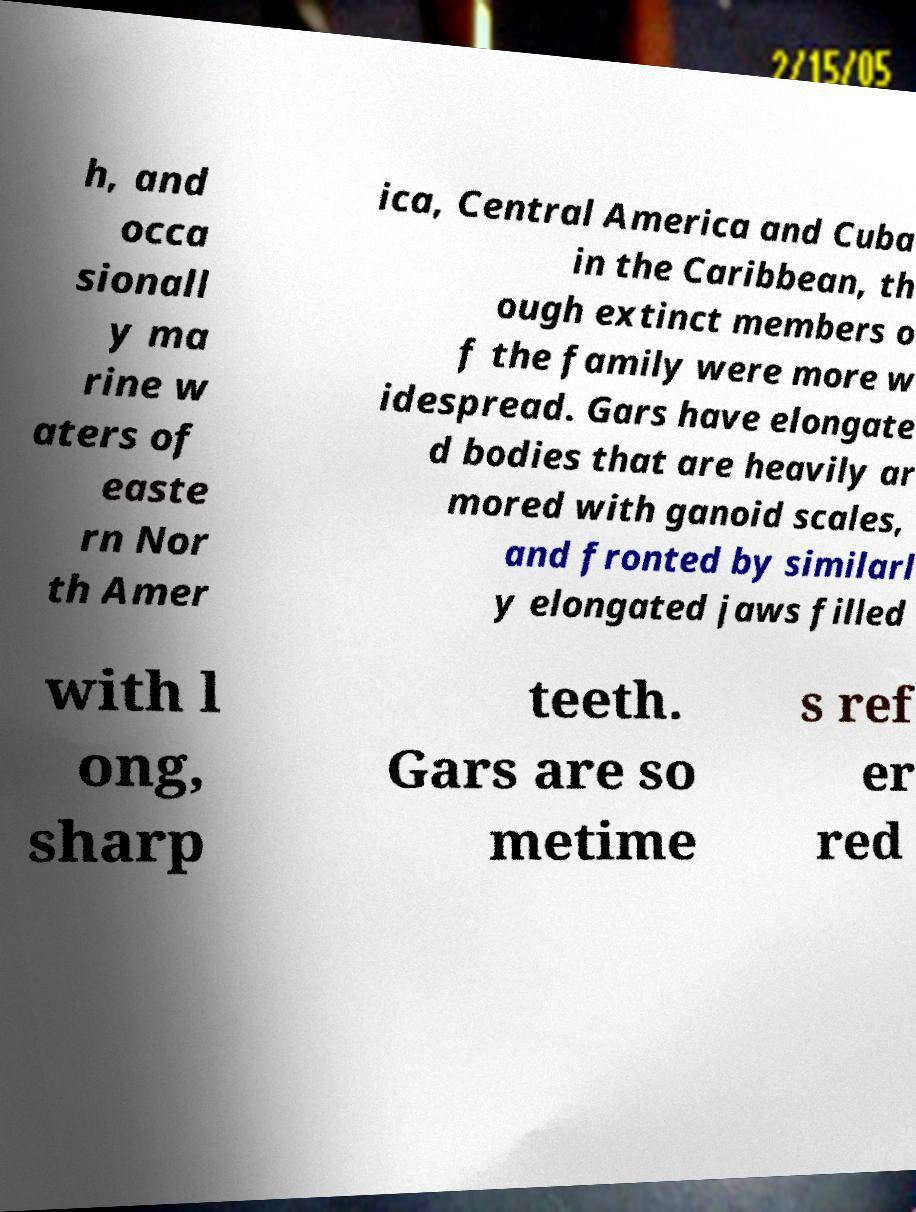For documentation purposes, I need the text within this image transcribed. Could you provide that? h, and occa sionall y ma rine w aters of easte rn Nor th Amer ica, Central America and Cuba in the Caribbean, th ough extinct members o f the family were more w idespread. Gars have elongate d bodies that are heavily ar mored with ganoid scales, and fronted by similarl y elongated jaws filled with l ong, sharp teeth. Gars are so metime s ref er red 